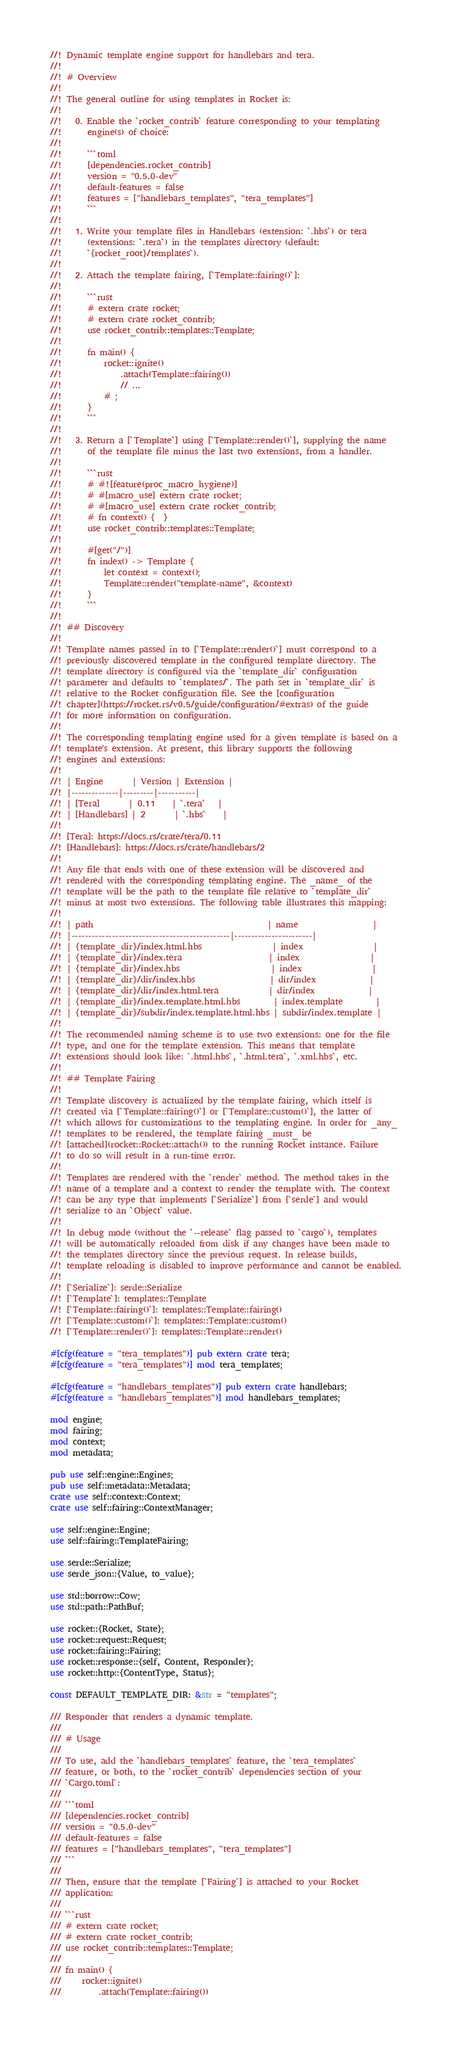Convert code to text. <code><loc_0><loc_0><loc_500><loc_500><_Rust_>//! Dynamic template engine support for handlebars and tera.
//!
//! # Overview
//!
//! The general outline for using templates in Rocket is:
//!
//!   0. Enable the `rocket_contrib` feature corresponding to your templating
//!      engine(s) of choice:
//!
//!      ```toml
//!      [dependencies.rocket_contrib]
//!      version = "0.5.0-dev"
//!      default-features = false
//!      features = ["handlebars_templates", "tera_templates"]
//!      ```
//!
//!   1. Write your template files in Handlebars (extension: `.hbs`) or tera
//!      (extensions: `.tera`) in the templates directory (default:
//!      `{rocket_root}/templates`).
//!
//!   2. Attach the template fairing, [`Template::fairing()`]:
//!
//!      ```rust
//!      # extern crate rocket;
//!      # extern crate rocket_contrib;
//!      use rocket_contrib::templates::Template;
//!
//!      fn main() {
//!          rocket::ignite()
//!              .attach(Template::fairing())
//!              // ...
//!          # ;
//!      }
//!      ```
//!
//!   3. Return a [`Template`] using [`Template::render()`], supplying the name
//!      of the template file minus the last two extensions, from a handler.
//!
//!      ```rust
//!      # #![feature(proc_macro_hygiene)]
//!      # #[macro_use] extern crate rocket;
//!      # #[macro_use] extern crate rocket_contrib;
//!      # fn context() {  }
//!      use rocket_contrib::templates::Template;
//!
//!      #[get("/")]
//!      fn index() -> Template {
//!          let context = context();
//!          Template::render("template-name", &context)
//!      }
//!      ```
//!
//! ## Discovery
//!
//! Template names passed in to [`Template::render()`] must correspond to a
//! previously discovered template in the configured template directory. The
//! template directory is configured via the `template_dir` configuration
//! parameter and defaults to `templates/`. The path set in `template_dir` is
//! relative to the Rocket configuration file. See the [configuration
//! chapter](https://rocket.rs/v0.5/guide/configuration/#extras) of the guide
//! for more information on configuration.
//!
//! The corresponding templating engine used for a given template is based on a
//! template's extension. At present, this library supports the following
//! engines and extensions:
//!
//! | Engine       | Version | Extension |
//! |--------------|---------|-----------|
//! | [Tera]       | 0.11    | `.tera`   |
//! | [Handlebars] | 2       | `.hbs`    |
//!
//! [Tera]: https://docs.rs/crate/tera/0.11
//! [Handlebars]: https://docs.rs/crate/handlebars/2
//!
//! Any file that ends with one of these extension will be discovered and
//! rendered with the corresponding templating engine. The _name_ of the
//! template will be the path to the template file relative to `template_dir`
//! minus at most two extensions. The following table illustrates this mapping:
//!
//! | path                                          | name                  |
//! |-----------------------------------------------|-----------------------|
//! | {template_dir}/index.html.hbs                 | index                 |
//! | {template_dir}/index.tera                     | index                 |
//! | {template_dir}/index.hbs                      | index                 |
//! | {template_dir}/dir/index.hbs                  | dir/index             |
//! | {template_dir}/dir/index.html.tera            | dir/index             |
//! | {template_dir}/index.template.html.hbs        | index.template        |
//! | {template_dir}/subdir/index.template.html.hbs | subdir/index.template |
//!
//! The recommended naming scheme is to use two extensions: one for the file
//! type, and one for the template extension. This means that template
//! extensions should look like: `.html.hbs`, `.html.tera`, `.xml.hbs`, etc.
//!
//! ## Template Fairing
//!
//! Template discovery is actualized by the template fairing, which itself is
//! created via [`Template::fairing()`] or [`Template::custom()`], the latter of
//! which allows for customizations to the templating engine. In order for _any_
//! templates to be rendered, the template fairing _must_ be
//! [attached](rocket::Rocket::attach()) to the running Rocket instance. Failure
//! to do so will result in a run-time error.
//!
//! Templates are rendered with the `render` method. The method takes in the
//! name of a template and a context to render the template with. The context
//! can be any type that implements [`Serialize`] from [`serde`] and would
//! serialize to an `Object` value.
//!
//! In debug mode (without the `--release` flag passed to `cargo`), templates
//! will be automatically reloaded from disk if any changes have been made to
//! the templates directory since the previous request. In release builds,
//! template reloading is disabled to improve performance and cannot be enabled.
//!
//! [`Serialize`]: serde::Serialize
//! [`Template`]: templates::Template
//! [`Template::fairing()`]: templates::Template::fairing()
//! [`Template::custom()`]: templates::Template::custom()
//! [`Template::render()`]: templates::Template::render()

#[cfg(feature = "tera_templates")] pub extern crate tera;
#[cfg(feature = "tera_templates")] mod tera_templates;

#[cfg(feature = "handlebars_templates")] pub extern crate handlebars;
#[cfg(feature = "handlebars_templates")] mod handlebars_templates;

mod engine;
mod fairing;
mod context;
mod metadata;

pub use self::engine::Engines;
pub use self::metadata::Metadata;
crate use self::context::Context;
crate use self::fairing::ContextManager;

use self::engine::Engine;
use self::fairing::TemplateFairing;

use serde::Serialize;
use serde_json::{Value, to_value};

use std::borrow::Cow;
use std::path::PathBuf;

use rocket::{Rocket, State};
use rocket::request::Request;
use rocket::fairing::Fairing;
use rocket::response::{self, Content, Responder};
use rocket::http::{ContentType, Status};

const DEFAULT_TEMPLATE_DIR: &str = "templates";

/// Responder that renders a dynamic template.
///
/// # Usage
///
/// To use, add the `handlebars_templates` feature, the `tera_templates`
/// feature, or both, to the `rocket_contrib` dependencies section of your
/// `Cargo.toml`:
///
/// ```toml
/// [dependencies.rocket_contrib]
/// version = "0.5.0-dev"
/// default-features = false
/// features = ["handlebars_templates", "tera_templates"]
/// ```
///
/// Then, ensure that the template [`Fairing`] is attached to your Rocket
/// application:
///
/// ```rust
/// # extern crate rocket;
/// # extern crate rocket_contrib;
/// use rocket_contrib::templates::Template;
///
/// fn main() {
///     rocket::ignite()
///         .attach(Template::fairing())</code> 